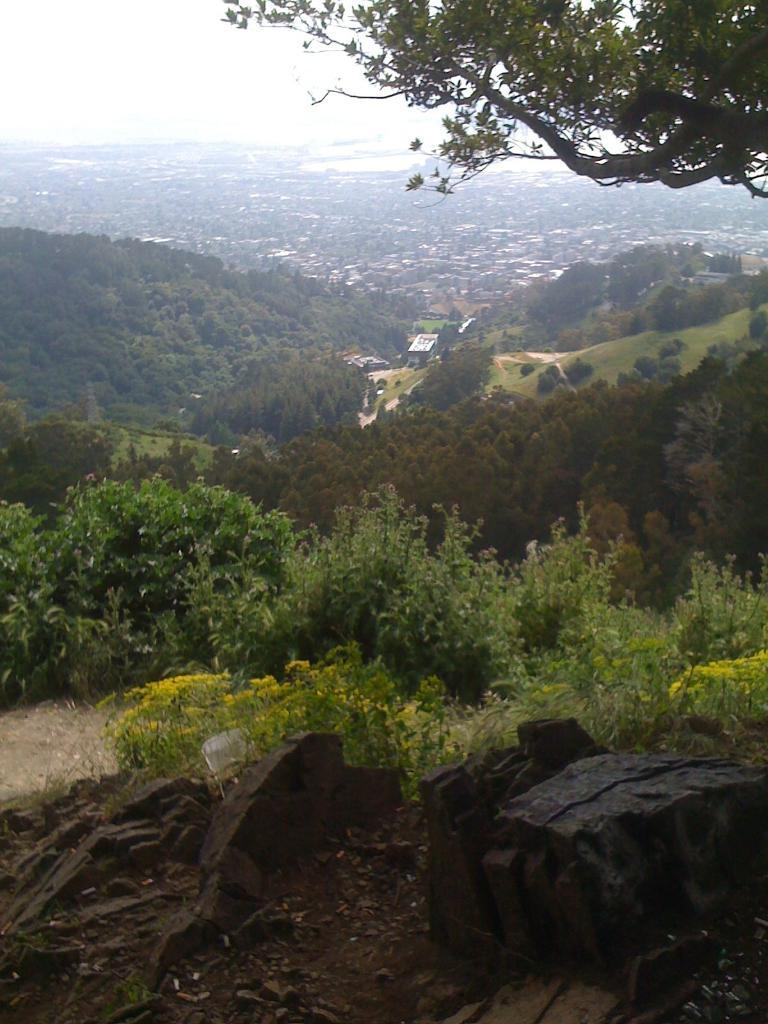What type of living organisms can be seen in the image? Plants can be seen in the image. What can be seen in the background of the image? There are trees and the sky visible in the background of the image. What is the price of the pizzas in the image? There are no pizzas present in the image, so it is not possible to determine their price. 